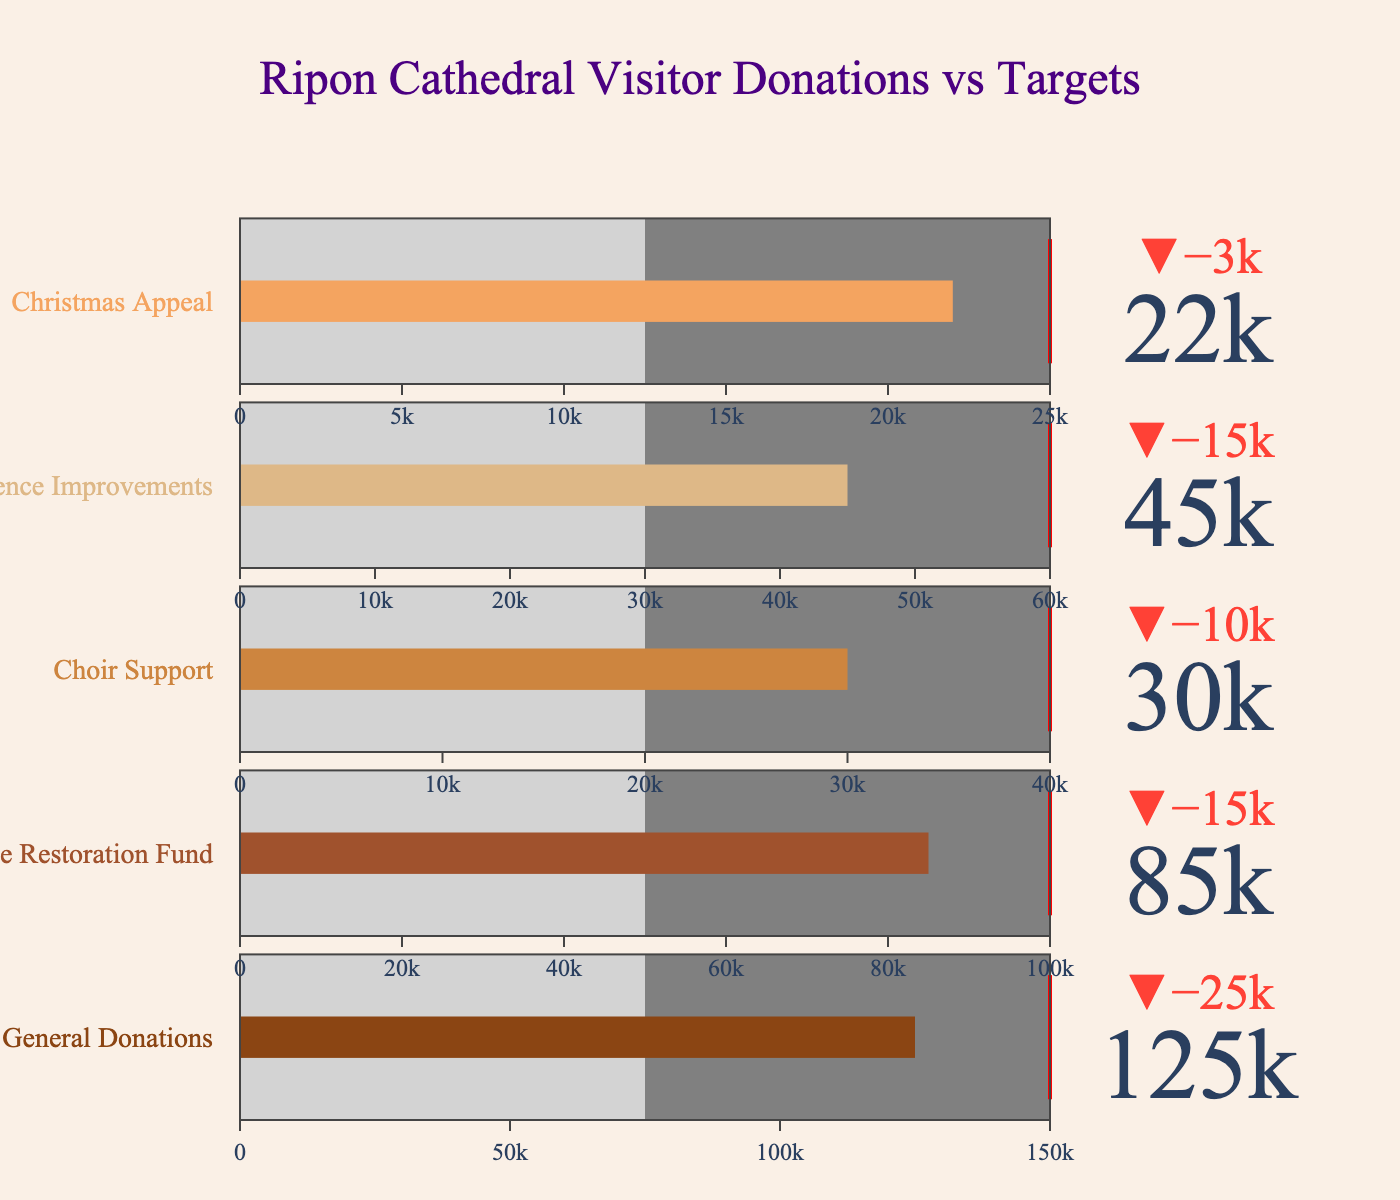What is the target amount for the Heritage Restoration Fund donations? The target amount for each category is listed to the right of the corresponding bar in the figure. For the Heritage Restoration Fund, the target amount is displayed in red.
Answer: 100,000 Which category has the highest actual donations? The actual donations value for each category is displayed near the bullet bar. By comparing these values, we can see that General Donations has the highest actual donations.
Answer: General Donations How much more is needed to meet the target for the Christmas Appeal? The actual donation for the Christmas Appeal is 22,000 and the target is 25,000. The difference is calculated by subtracting the actual amount from the target amount: 25,000 - 22,000 = 3,000.
Answer: 3,000 What is the difference between the target and actual donations for the Choir Support? The actual donations for the Choir Support are 30,000 and the target is 40,000. The difference is 40,000 - 30,000 = 10,000.
Answer: 10,000 Are any categories' actual donations equal to their target donations? By examining the bars and the red target lines, we can see if any of the actual values align exactly with the targets. In this case, none of the actual donations reach their target donations.
Answer: No Which category is closest to reaching its target? To determine which category is closest to its target, we need to find the smallest difference between actual and target amounts. The Christmas Appeal has actual donations of 22,000 and a target of 25,000, so the difference is 3,000, which is the smallest among all categories.
Answer: Christmas Appeal What percentage of its target has the Visitor Experience Improvements achieved? The actual donations for the Visitor Experience Improvements is 45,000 and the target is 60,000. The percentage achieved is (45,000 / 60,000) * 100 = 75%.
Answer: 75% Which category has the lowest actual donations? By comparing the actual donation values for all categories, we see that the Christmas Appeal has the lowest amount at 22,000.
Answer: Christmas Appeal How much more does the General Donations category need to surpass its target? To surpass its target, General Donations need to exceed 150,000. The actual amount is 125,000. Hence, it needs to get 150,000 - 125,000 = 25,000 more to reach the target.
Answer: 25,000 Is the actual donation for the Heritage Restoration Fund less than, equal to, or greater than the halfway mark of its target? The target for the Heritage Restoration Fund is 100,000. The halfway mark of this target is 50,000. The actual donation is 85,000, which is greater than 50,000.
Answer: Greater than 